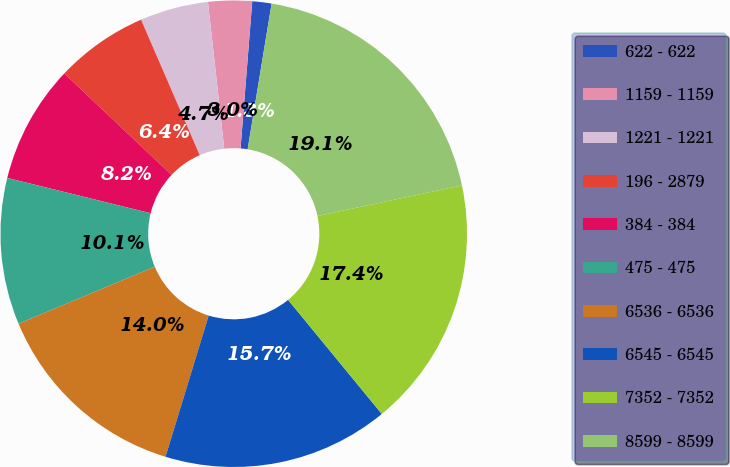Convert chart to OTSL. <chart><loc_0><loc_0><loc_500><loc_500><pie_chart><fcel>622 - 622<fcel>1159 - 1159<fcel>1221 - 1221<fcel>196 - 2879<fcel>384 - 384<fcel>475 - 475<fcel>6536 - 6536<fcel>6545 - 6545<fcel>7352 - 7352<fcel>8599 - 8599<nl><fcel>1.33%<fcel>3.03%<fcel>4.74%<fcel>6.44%<fcel>8.21%<fcel>10.15%<fcel>13.97%<fcel>15.67%<fcel>17.38%<fcel>19.08%<nl></chart> 